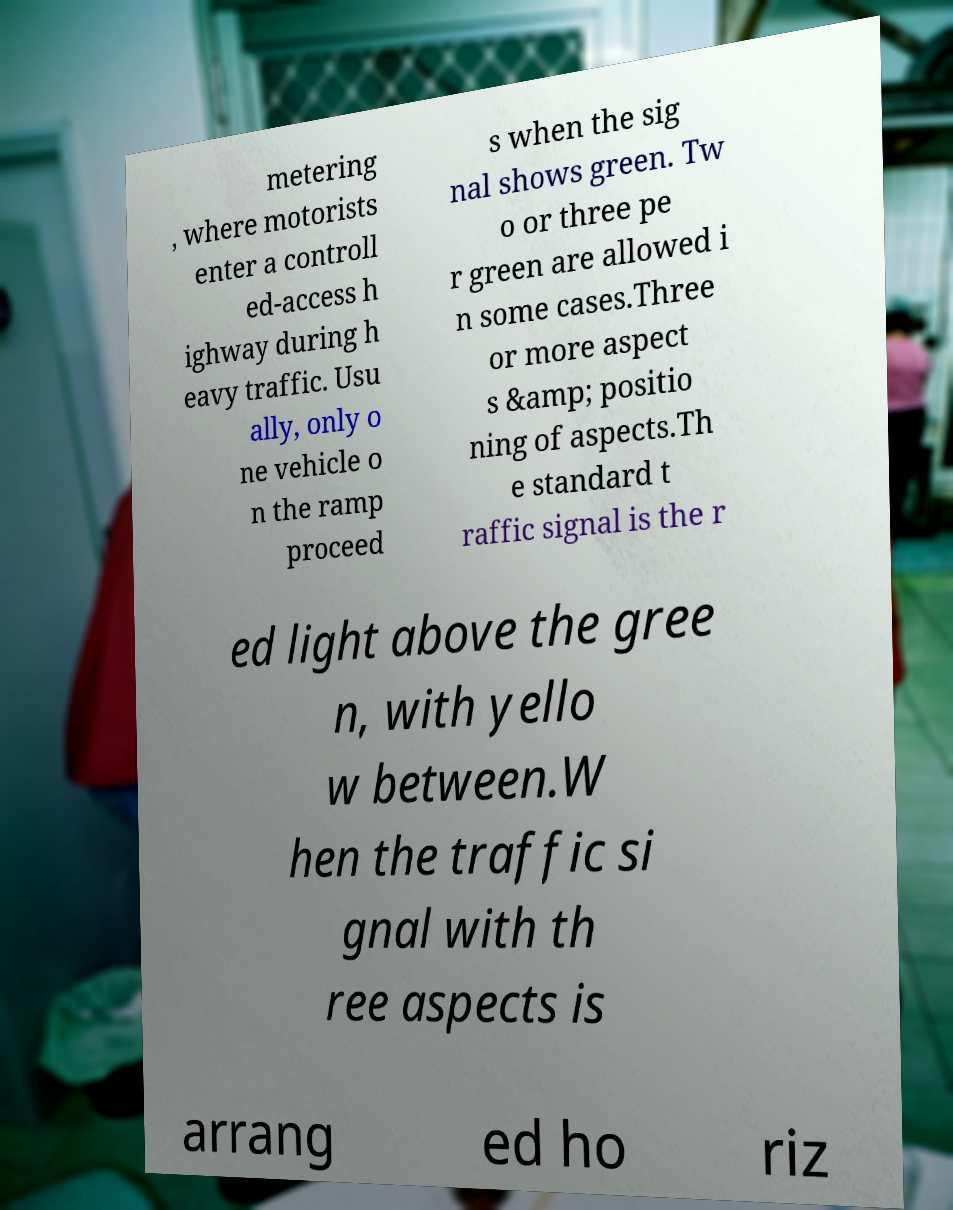There's text embedded in this image that I need extracted. Can you transcribe it verbatim? metering , where motorists enter a controll ed-access h ighway during h eavy traffic. Usu ally, only o ne vehicle o n the ramp proceed s when the sig nal shows green. Tw o or three pe r green are allowed i n some cases.Three or more aspect s &amp; positio ning of aspects.Th e standard t raffic signal is the r ed light above the gree n, with yello w between.W hen the traffic si gnal with th ree aspects is arrang ed ho riz 